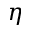Convert formula to latex. <formula><loc_0><loc_0><loc_500><loc_500>\eta</formula> 